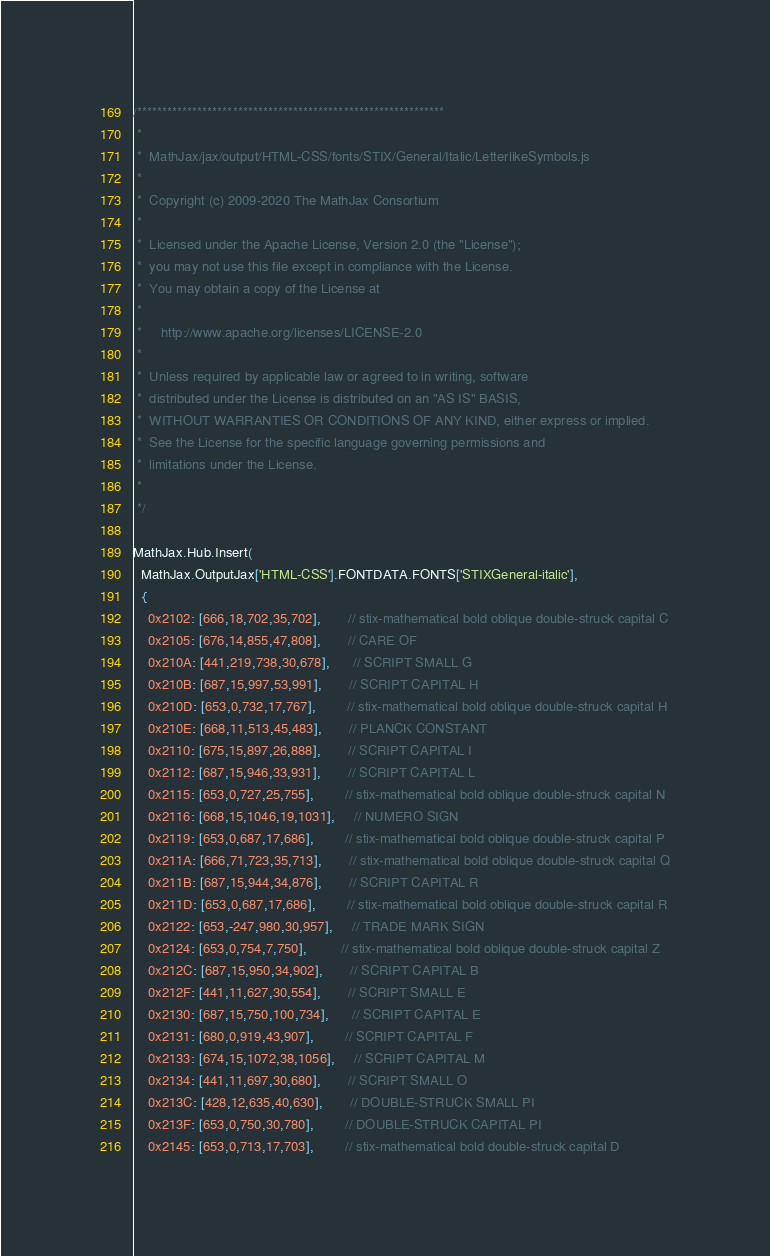Convert code to text. <code><loc_0><loc_0><loc_500><loc_500><_JavaScript_>/*************************************************************
 *
 *  MathJax/jax/output/HTML-CSS/fonts/STIX/General/Italic/LetterlikeSymbols.js
 *
 *  Copyright (c) 2009-2020 The MathJax Consortium
 *
 *  Licensed under the Apache License, Version 2.0 (the "License");
 *  you may not use this file except in compliance with the License.
 *  You may obtain a copy of the License at
 *
 *     http://www.apache.org/licenses/LICENSE-2.0
 *
 *  Unless required by applicable law or agreed to in writing, software
 *  distributed under the License is distributed on an "AS IS" BASIS,
 *  WITHOUT WARRANTIES OR CONDITIONS OF ANY KIND, either express or implied.
 *  See the License for the specific language governing permissions and
 *  limitations under the License.
 *
 */

MathJax.Hub.Insert(
  MathJax.OutputJax['HTML-CSS'].FONTDATA.FONTS['STIXGeneral-italic'],
  {
    0x2102: [666,18,702,35,702],       // stix-mathematical bold oblique double-struck capital C
    0x2105: [676,14,855,47,808],       // CARE OF
    0x210A: [441,219,738,30,678],      // SCRIPT SMALL G
    0x210B: [687,15,997,53,991],       // SCRIPT CAPITAL H
    0x210D: [653,0,732,17,767],        // stix-mathematical bold oblique double-struck capital H
    0x210E: [668,11,513,45,483],       // PLANCK CONSTANT
    0x2110: [675,15,897,26,888],       // SCRIPT CAPITAL I
    0x2112: [687,15,946,33,931],       // SCRIPT CAPITAL L
    0x2115: [653,0,727,25,755],        // stix-mathematical bold oblique double-struck capital N
    0x2116: [668,15,1046,19,1031],     // NUMERO SIGN
    0x2119: [653,0,687,17,686],        // stix-mathematical bold oblique double-struck capital P
    0x211A: [666,71,723,35,713],       // stix-mathematical bold oblique double-struck capital Q
    0x211B: [687,15,944,34,876],       // SCRIPT CAPITAL R
    0x211D: [653,0,687,17,686],        // stix-mathematical bold oblique double-struck capital R
    0x2122: [653,-247,980,30,957],     // TRADE MARK SIGN
    0x2124: [653,0,754,7,750],         // stix-mathematical bold oblique double-struck capital Z
    0x212C: [687,15,950,34,902],       // SCRIPT CAPITAL B
    0x212F: [441,11,627,30,554],       // SCRIPT SMALL E
    0x2130: [687,15,750,100,734],      // SCRIPT CAPITAL E
    0x2131: [680,0,919,43,907],        // SCRIPT CAPITAL F
    0x2133: [674,15,1072,38,1056],     // SCRIPT CAPITAL M
    0x2134: [441,11,697,30,680],       // SCRIPT SMALL O
    0x213C: [428,12,635,40,630],       // DOUBLE-STRUCK SMALL PI
    0x213F: [653,0,750,30,780],        // DOUBLE-STRUCK CAPITAL PI
    0x2145: [653,0,713,17,703],        // stix-mathematical bold double-struck capital D</code> 